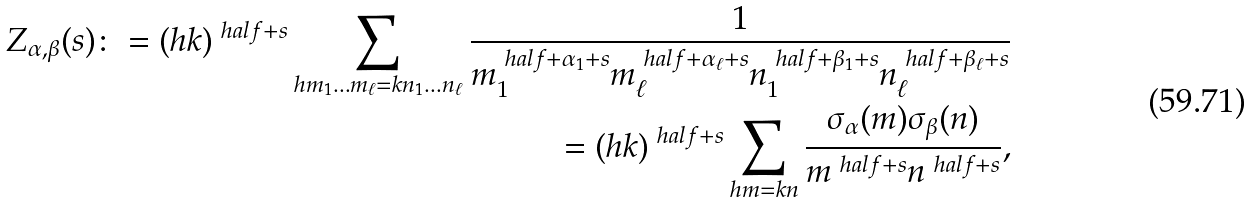<formula> <loc_0><loc_0><loc_500><loc_500>Z _ { \alpha , \beta } ( s ) \colon = ( h k ) ^ { \ h a l f + s } \sum _ { h m _ { 1 } \dots m _ { \ell } = k n _ { 1 } \dots n _ { \ell } } \frac { 1 } { m _ { 1 } ^ { \ h a l f + \alpha _ { 1 } + s } m _ { \ell } ^ { \ h a l f + \alpha _ { \ell } + s } n _ { 1 } ^ { \ h a l f + \beta _ { 1 } + s } n _ { \ell } ^ { \ h a l f + \beta _ { \ell } + s } } \\ = ( h k ) ^ { \ h a l f + s } \sum _ { h m = k n } \frac { \sigma _ { \alpha } ( m ) \sigma _ { \beta } ( n ) } { m ^ { \ h a l f + s } n ^ { \ h a l f + s } } ,</formula> 